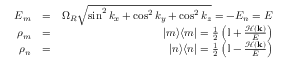Convert formula to latex. <formula><loc_0><loc_0><loc_500><loc_500>\begin{array} { r l r } { E _ { m } } & { = } & { \Omega _ { R } \sqrt { \sin ^ { 2 } k _ { x } + \cos ^ { 2 } k _ { y } + \cos ^ { 2 } k _ { z } } = - E _ { n } = E } \\ { \rho _ { m } } & { = } & { | m \rangle \langle m | = \frac { 1 } { 2 } \left ( \mathbb { I } + \frac { \mathcal { H } ( k ) } { E } \right ) } \\ { \rho _ { n } } & { = } & { | n \rangle \langle n | = \frac { 1 } { 2 } \left ( \mathbb { I } - \frac { \mathcal { H } ( k ) } { E } \right ) } \end{array}</formula> 